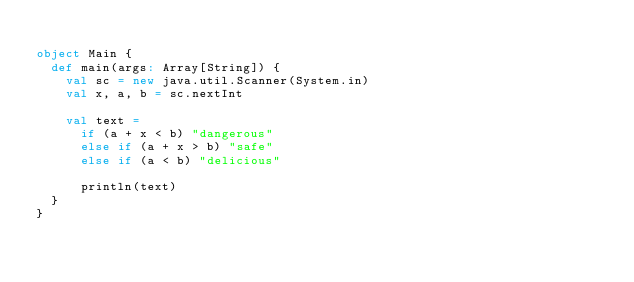Convert code to text. <code><loc_0><loc_0><loc_500><loc_500><_Scala_>
object Main {
  def main(args: Array[String]) {
    val sc = new java.util.Scanner(System.in)
    val x, a, b = sc.nextInt

    val text =
      if (a + x < b) "dangerous"
      else if (a + x > b) "safe"
      else if (a < b) "delicious"

      println(text)
  }
}

</code> 